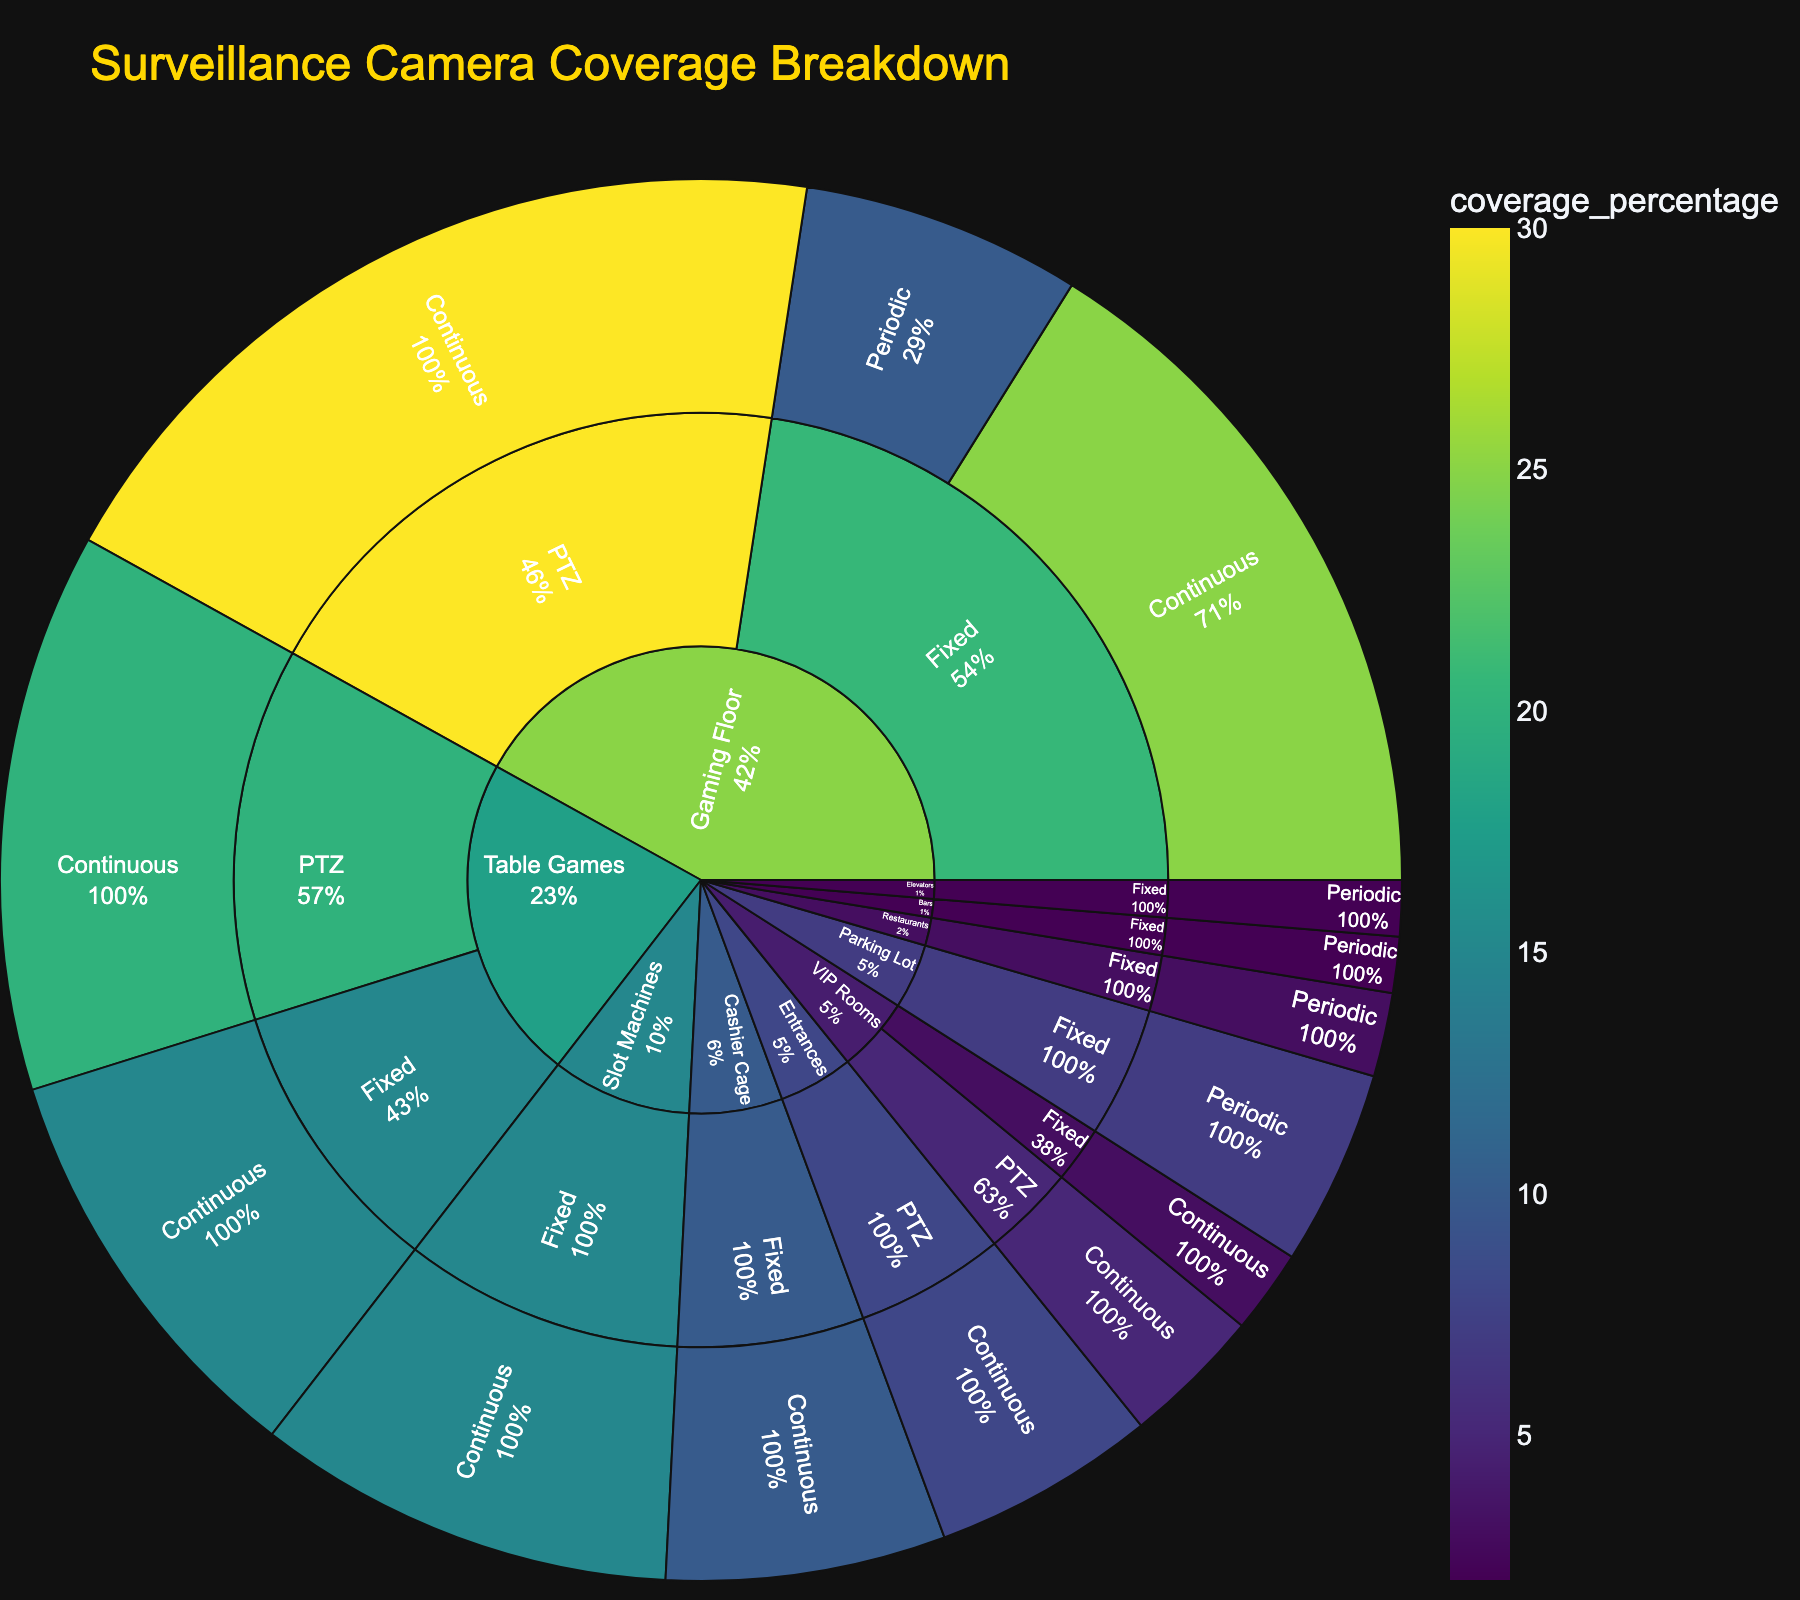what section has the highest overall camera coverage percentage? To find the section with the highest overall camera coverage, look at the outermost ring of the sunburst plot and identify the largest segment. The Gaming Floor section has the largest portion in the plot.
Answer: Gaming Floor How much coverage percentage is provided by PTZ cameras in VIP Rooms? Trace the path from the center to the VIP Rooms section and then to the PTZ cameras. The percentage coverage of PTZ cameras in VIP Rooms is clearly labeled as 5%.
Answer: 5% Which section has the least coverage percentage with fixed cameras used periodically? Look for sections that use fixed cameras in a periodic monitoring frequency. The smallest coverage percentage among those is visible in the Elevators category with 2%.
Answer: Elevators What is the total coverage percentage for Table Games section? Add the coverage percentages for all camera types and monitoring frequencies within the Table Games section. It includes PTZ cameras with 20% coverage and fixed cameras with 15% coverage. Sum them up: 20 + 15 = 35%.
Answer: 35% How does the coverage percentage of Fixed cameras on the Gaming Floor compare with those on the Slot Machines? Compare the fixed camera percentages on the sunburst plot for Gaming Floor and Slot Machines. Gaming Floor has fixed cameras with 25% (continuous) + 10% (periodic) totaling 35%, whereas Slot Machines have 15% continuous coverage. So, Gaming Floor's fixed cameras cover more.
Answer: More on Gaming Floor What's the combined coverage percentage of the Parking Lot and Entrances sections? Look at the coverage percentages for Parking Lot and Entrances. Parking Lot has 7% and Entrances has 8%. Adding both gives 7 + 8 = 15%.
Answer: 15% What section uses PTZ cameras exclusively? Find a section that only lists PTZ cameras in the plot. VIP Rooms uses both PTZ and Fixed, so this is not exclusive. Similarly, Entrances and Table Games use PTZ exclusively.
Answer: Entrances How many sections have fixed cameras monitored periodically? Identify all the distinct sections in the plot where fixed cameras are monitored periodically. These sections are Gaming Floor (10%), Parking Lot (7%), Elevators (2%), Restaurants (3%), and Bars (2%) which totals to 5 sections.
Answer: 5 What's the highest coverage percentage of continuous monitoring with fixed cameras in any section? Look at all sections with fixed cameras and continuous monitoring. The highest percentage within those is 25% on the Gaming Floor.
Answer: 25% Which has a higher coverage percentage: PTZ cameras in Table Games or fixed cameras in Restaurants? Compare the values: PTZ cameras in Table Games have 20%, and fixed cameras in Restaurants have 3%. 20% is greater than 3%, so Table Games PTZ cameras have a higher percentage.
Answer: PTZ cameras in Table Games 